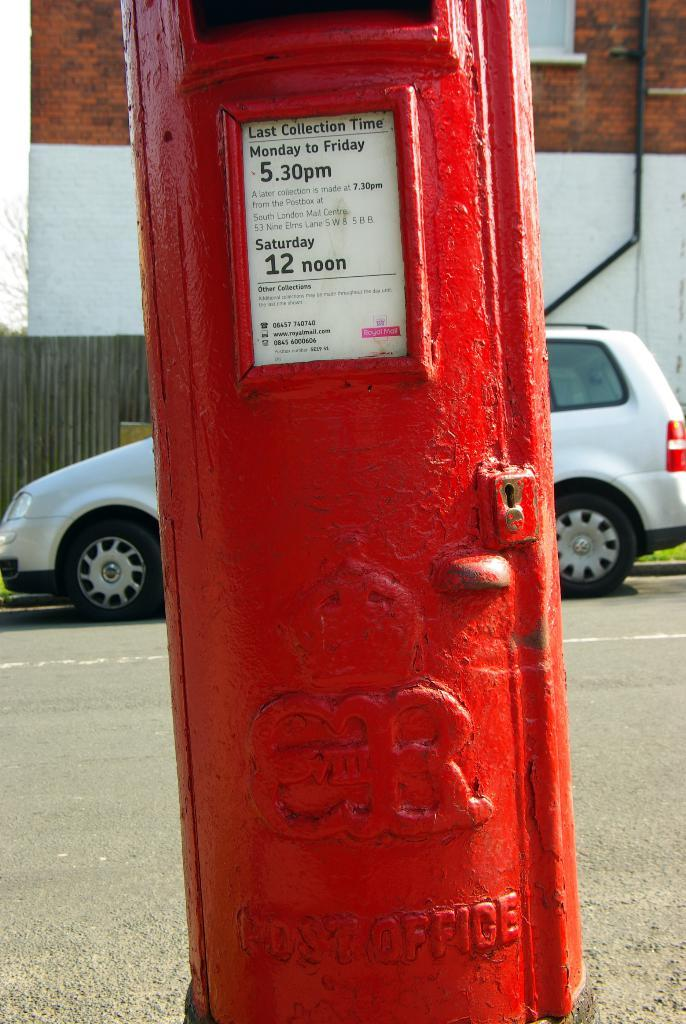What is the color of the post box in the image? The post box in the image is red. What is located behind the post box in the image? There is a white color vehicle behind the post box. What can be seen in the background of the image? There is a wall and the sky visible in the background of the image. What type of company is represented by the post box in the image? The image does not provide information about any company; it simply shows a red post box. 